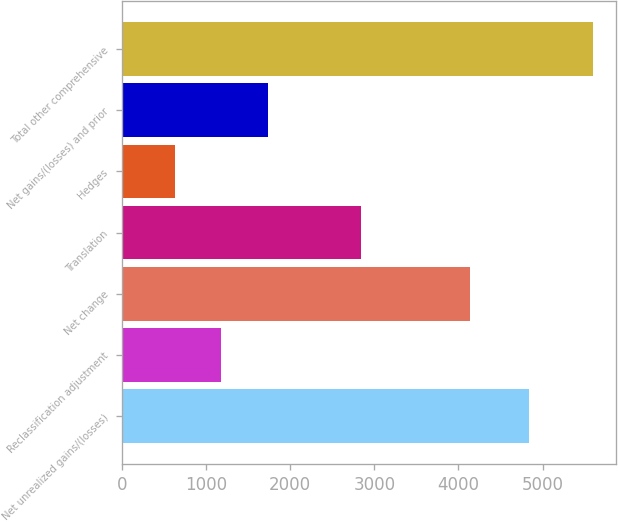Convert chart. <chart><loc_0><loc_0><loc_500><loc_500><bar_chart><fcel>Net unrealized gains/(losses)<fcel>Reclassification adjustment<fcel>Net change<fcel>Translation<fcel>Hedges<fcel>Net gains/(losses) and prior<fcel>Total other comprehensive<nl><fcel>4841<fcel>1180<fcel>4133<fcel>2836<fcel>628<fcel>1732<fcel>5596<nl></chart> 